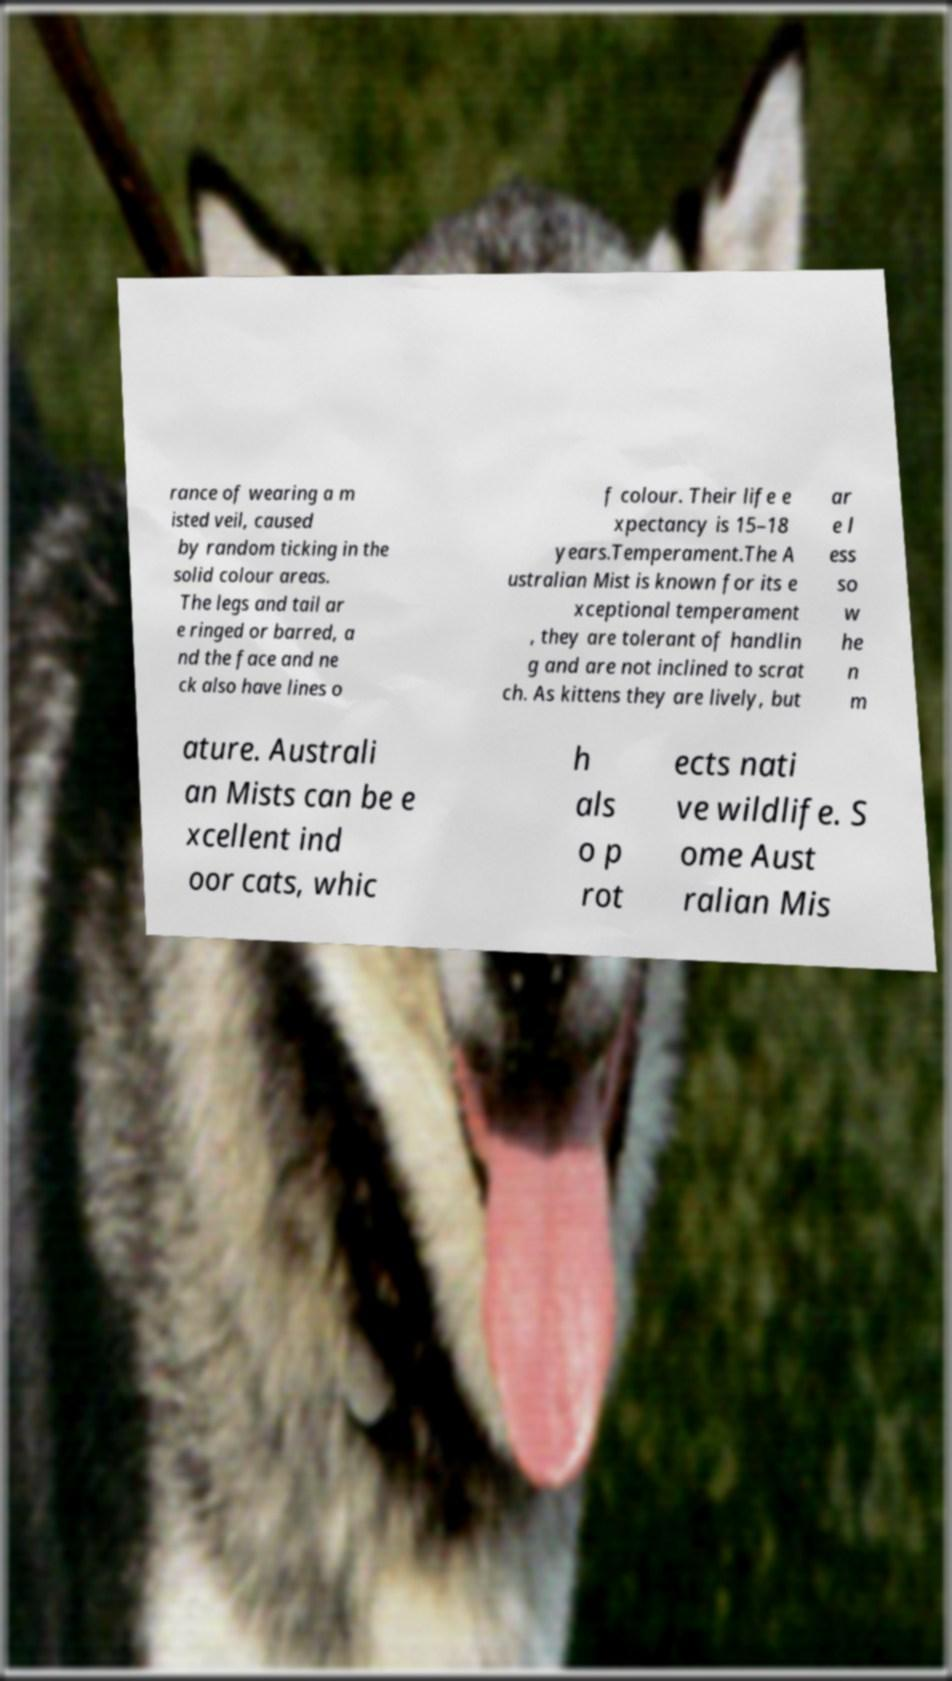I need the written content from this picture converted into text. Can you do that? rance of wearing a m isted veil, caused by random ticking in the solid colour areas. The legs and tail ar e ringed or barred, a nd the face and ne ck also have lines o f colour. Their life e xpectancy is 15–18 years.Temperament.The A ustralian Mist is known for its e xceptional temperament , they are tolerant of handlin g and are not inclined to scrat ch. As kittens they are lively, but ar e l ess so w he n m ature. Australi an Mists can be e xcellent ind oor cats, whic h als o p rot ects nati ve wildlife. S ome Aust ralian Mis 